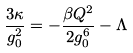Convert formula to latex. <formula><loc_0><loc_0><loc_500><loc_500>\frac { 3 \kappa } { g _ { 0 } ^ { 2 } } = - \frac { \beta Q ^ { 2 } } { 2 g _ { 0 } ^ { 6 } } - \Lambda \,</formula> 